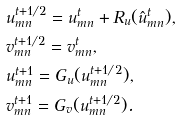Convert formula to latex. <formula><loc_0><loc_0><loc_500><loc_500>& u ^ { t + 1 / 2 } _ { m n } = u ^ { t } _ { m n } + R _ { u } ( \hat { u } ^ { t } _ { m n } ) , \\ & v ^ { t + 1 / 2 } _ { m n } = v ^ { t } _ { m n } , \\ & u ^ { t + 1 } _ { m n } = G _ { u } ( u ^ { t + 1 / 2 } _ { m n } ) , \\ & v ^ { t + 1 } _ { m n } = G _ { v } ( u ^ { t + 1 / 2 } _ { m n } ) .</formula> 